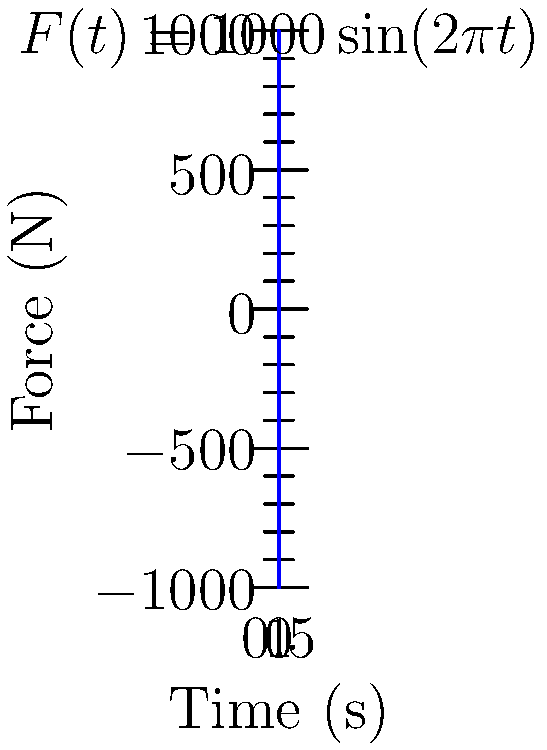A simply supported beam of length $L = 2$ m, elastic modulus $E = 200$ GPa, and moment of inertia $I = 1.5 \times 10^{-6}$ m⁴ is subjected to a harmonic force $F(t) = 1000\sin(2\pi t)$ N at its midpoint, as shown in the force-time graph. Calculate the maximum deflection of the beam at its midpoint. Assume the beam's mass is negligible compared to the applied force. To solve this problem, we'll follow these steps:

1) The maximum deflection for a simply supported beam with a concentrated load at the midpoint is given by:

   $$y_{max} = \frac{FL^3}{48EI}$$

   where $F$ is the maximum force, $L$ is the beam length, $E$ is the elastic modulus, and $I$ is the moment of inertia.

2) From the given force-time graph, we can see that the maximum force is 1000 N.

3) Substituting the values:
   $F = 1000$ N
   $L = 2$ m
   $E = 200 \times 10^9$ Pa
   $I = 1.5 \times 10^{-6}$ m⁴

4) Calculate:
   $$y_{max} = \frac{1000 \times 2^3}{48 \times 200 \times 10^9 \times 1.5 \times 10^{-6}}$$

5) Simplify:
   $$y_{max} = \frac{8000}{14.4 \times 10^6} = 5.56 \times 10^{-4}$$ m

6) Convert to mm for a more practical unit:
   $$y_{max} = 0.556$$ mm

Therefore, the maximum deflection of the beam at its midpoint is 0.556 mm.
Answer: 0.556 mm 